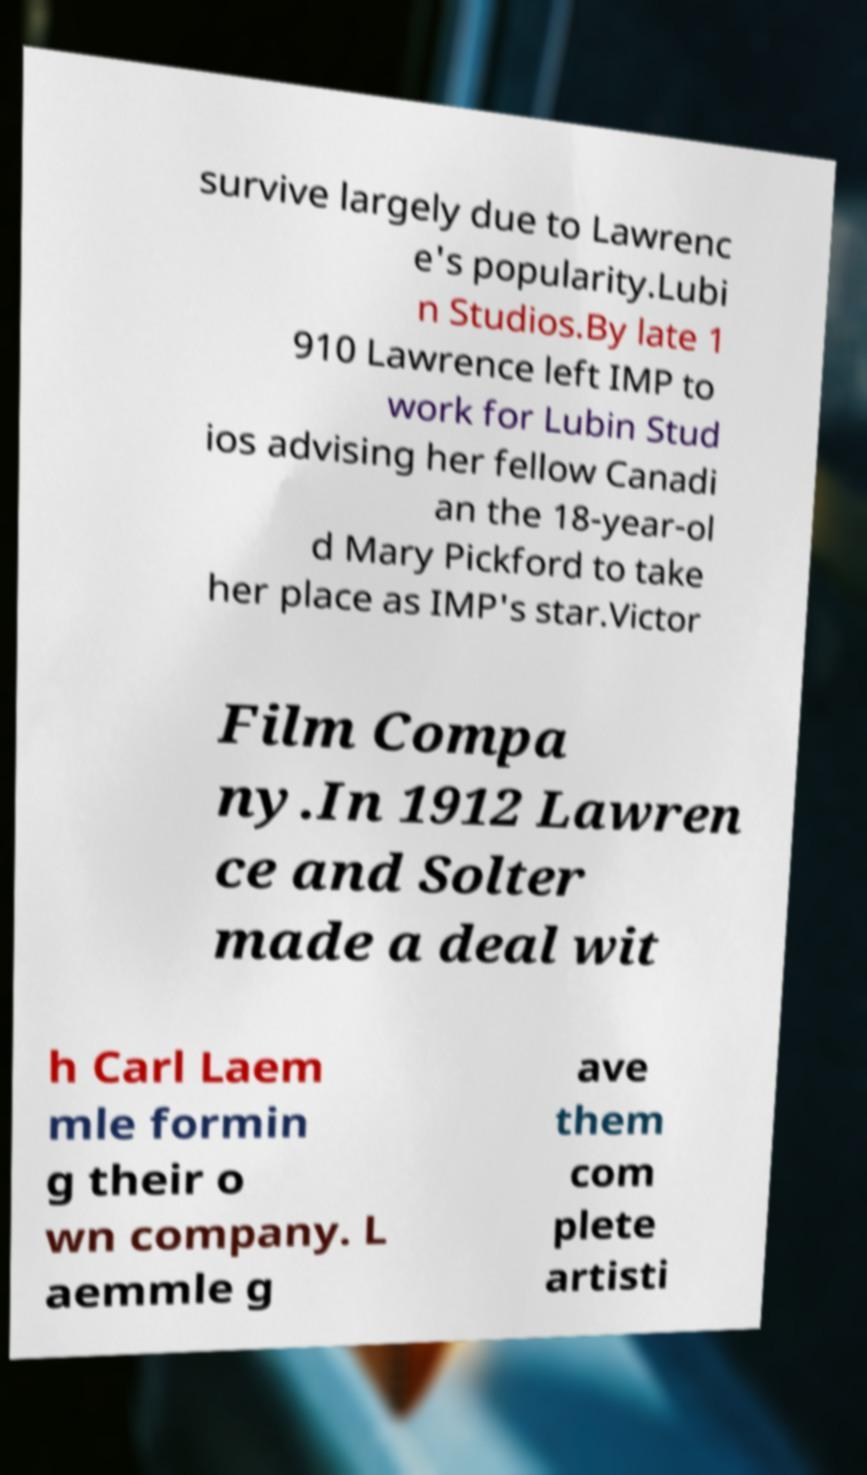There's text embedded in this image that I need extracted. Can you transcribe it verbatim? survive largely due to Lawrenc e's popularity.Lubi n Studios.By late 1 910 Lawrence left IMP to work for Lubin Stud ios advising her fellow Canadi an the 18-year-ol d Mary Pickford to take her place as IMP's star.Victor Film Compa ny.In 1912 Lawren ce and Solter made a deal wit h Carl Laem mle formin g their o wn company. L aemmle g ave them com plete artisti 